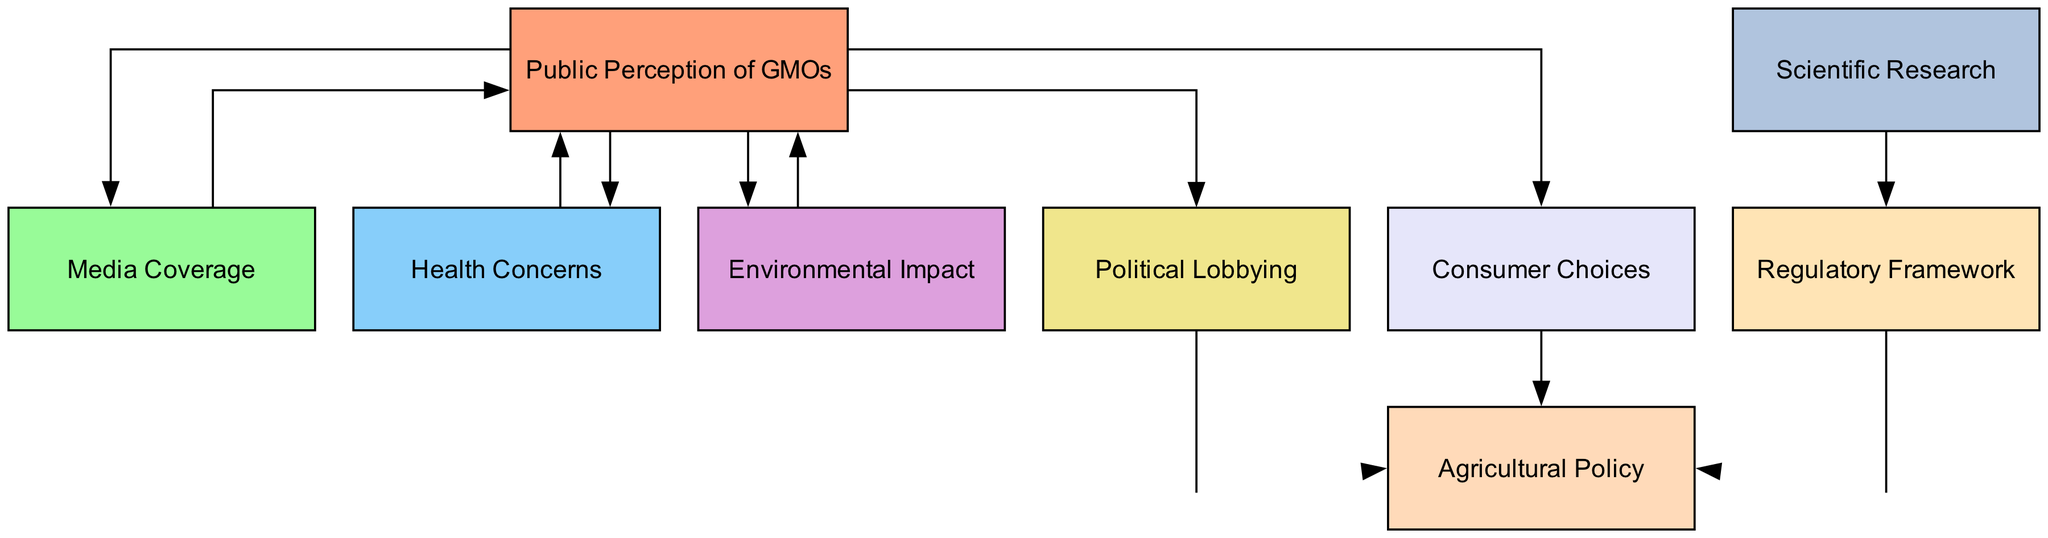What is the total number of nodes in the diagram? The diagram lists nine unique concepts, each represented by a node: Public Perception of GMOs, Media Coverage, Health Concerns, Environmental Impact, Political Lobbying, Consumer Choices, Regulatory Framework, Scientific Research, and Agricultural Policy. Counting these yields a total of nine nodes.
Answer: 9 Which node directly influences Consumer Choices? The diagram shows that Public Perception of GMOs has a direct influence on Consumer Choices, indicated by a directed edge leading from the former to the latter.
Answer: Public Perception of GMOs Which nodes are affected by Health Concerns? Health Concerns influences Public Perception of GMOs but does not have edges leading to any other nodes, indicating it only impacts one other node. Thus, the only node it affects is Public Perception of GMOs.
Answer: Public Perception of GMOs How many edges originate from the Public Perception of GMOs node? By reviewing the edges originating from the Public Perception of GMOs node in the diagram, we observe it leads to four other nodes: Media Coverage, Health Concerns, Environmental Impact, and Consumer Choices. Counting these gives us a total of four edges.
Answer: 4 Which node leads to Agricultural Policy through Political Lobbying? The diagram shows a directed edge from Political Lobbying directly to Agricultural Policy. No other nodes lead to Agricultural Policy through Political Lobbying, making it the sole node responsible for this interaction in the diagram.
Answer: Political Lobbying What is the relationship between Scientific Research and Agricultural Policy? The diagram depicts that Scientific Research influences the Regulatory Framework, which in turn leads to Agricultural Policy. To see the relationship: Scientific Research → Regulatory Framework → Agricultural Policy indicates the indirect relationship through the regulatory pathway.
Answer: Indirect via Regulatory Framework Which factors contribute to Public Perception of GMOs? The diagram illustrates that Media Coverage, Health Concerns, Environmental Impact, and Political Lobbying all contribute to Public Perception of GMOs, as there are directed edges from each of these nodes to the Public Perception of GMOs node. Counting these gives four contributing factors.
Answer: Media Coverage, Health Concerns, Environmental Impact, Political Lobbying What is the flow direction in the relationship from Consumer Choices to Agricultural Policy? The diagram indicates a directed edge that flows from Consumer Choices directly to Agricultural Policy, representing a clear influence. There are no nodes that affect this direction. Therefore, it is a straightforward flow from Consumer Choices to Agricultural Policy.
Answer: Consumer Choices to Agricultural Policy Which node has the highest number of edges leading to it? By analyzing the nodes and counting the number of incoming edges, we see Public Perception of GMOs has the most connections, with five edges directed toward it from Media Coverage, Health Concerns, Environmental Impact, Consumer Choices, and Political Lobbying.
Answer: Public Perception of GMOs 